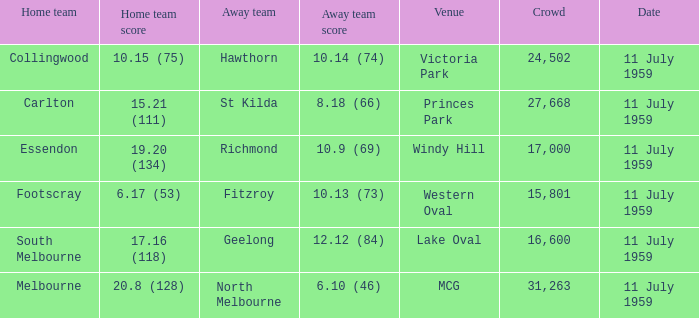How many points does footscray score as the home side? 6.17 (53). 